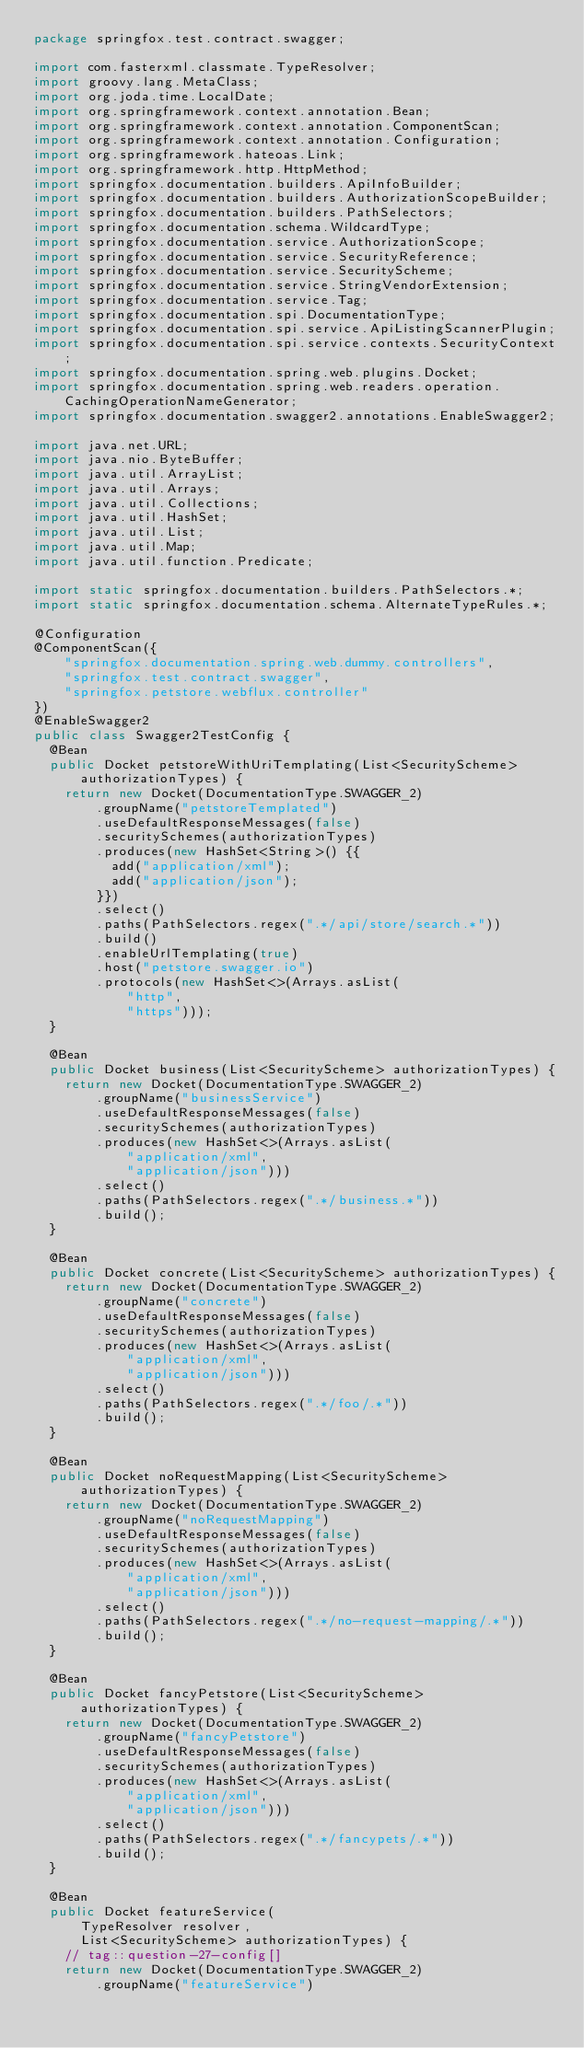<code> <loc_0><loc_0><loc_500><loc_500><_Java_>package springfox.test.contract.swagger;

import com.fasterxml.classmate.TypeResolver;
import groovy.lang.MetaClass;
import org.joda.time.LocalDate;
import org.springframework.context.annotation.Bean;
import org.springframework.context.annotation.ComponentScan;
import org.springframework.context.annotation.Configuration;
import org.springframework.hateoas.Link;
import org.springframework.http.HttpMethod;
import springfox.documentation.builders.ApiInfoBuilder;
import springfox.documentation.builders.AuthorizationScopeBuilder;
import springfox.documentation.builders.PathSelectors;
import springfox.documentation.schema.WildcardType;
import springfox.documentation.service.AuthorizationScope;
import springfox.documentation.service.SecurityReference;
import springfox.documentation.service.SecurityScheme;
import springfox.documentation.service.StringVendorExtension;
import springfox.documentation.service.Tag;
import springfox.documentation.spi.DocumentationType;
import springfox.documentation.spi.service.ApiListingScannerPlugin;
import springfox.documentation.spi.service.contexts.SecurityContext;
import springfox.documentation.spring.web.plugins.Docket;
import springfox.documentation.spring.web.readers.operation.CachingOperationNameGenerator;
import springfox.documentation.swagger2.annotations.EnableSwagger2;

import java.net.URL;
import java.nio.ByteBuffer;
import java.util.ArrayList;
import java.util.Arrays;
import java.util.Collections;
import java.util.HashSet;
import java.util.List;
import java.util.Map;
import java.util.function.Predicate;

import static springfox.documentation.builders.PathSelectors.*;
import static springfox.documentation.schema.AlternateTypeRules.*;

@Configuration
@ComponentScan({
    "springfox.documentation.spring.web.dummy.controllers",
    "springfox.test.contract.swagger",
    "springfox.petstore.webflux.controller"
})
@EnableSwagger2
public class Swagger2TestConfig {
  @Bean
  public Docket petstoreWithUriTemplating(List<SecurityScheme> authorizationTypes) {
    return new Docket(DocumentationType.SWAGGER_2)
        .groupName("petstoreTemplated")
        .useDefaultResponseMessages(false)
        .securitySchemes(authorizationTypes)
        .produces(new HashSet<String>() {{
          add("application/xml");
          add("application/json");
        }})
        .select()
        .paths(PathSelectors.regex(".*/api/store/search.*"))
        .build()
        .enableUrlTemplating(true)
        .host("petstore.swagger.io")
        .protocols(new HashSet<>(Arrays.asList(
            "http",
            "https")));
  }

  @Bean
  public Docket business(List<SecurityScheme> authorizationTypes) {
    return new Docket(DocumentationType.SWAGGER_2)
        .groupName("businessService")
        .useDefaultResponseMessages(false)
        .securitySchemes(authorizationTypes)
        .produces(new HashSet<>(Arrays.asList(
            "application/xml",
            "application/json")))
        .select()
        .paths(PathSelectors.regex(".*/business.*"))
        .build();
  }

  @Bean
  public Docket concrete(List<SecurityScheme> authorizationTypes) {
    return new Docket(DocumentationType.SWAGGER_2)
        .groupName("concrete")
        .useDefaultResponseMessages(false)
        .securitySchemes(authorizationTypes)
        .produces(new HashSet<>(Arrays.asList(
            "application/xml",
            "application/json")))
        .select()
        .paths(PathSelectors.regex(".*/foo/.*"))
        .build();
  }

  @Bean
  public Docket noRequestMapping(List<SecurityScheme> authorizationTypes) {
    return new Docket(DocumentationType.SWAGGER_2)
        .groupName("noRequestMapping")
        .useDefaultResponseMessages(false)
        .securitySchemes(authorizationTypes)
        .produces(new HashSet<>(Arrays.asList(
            "application/xml",
            "application/json")))
        .select()
        .paths(PathSelectors.regex(".*/no-request-mapping/.*"))
        .build();
  }

  @Bean
  public Docket fancyPetstore(List<SecurityScheme> authorizationTypes) {
    return new Docket(DocumentationType.SWAGGER_2)
        .groupName("fancyPetstore")
        .useDefaultResponseMessages(false)
        .securitySchemes(authorizationTypes)
        .produces(new HashSet<>(Arrays.asList(
            "application/xml",
            "application/json")))
        .select()
        .paths(PathSelectors.regex(".*/fancypets/.*"))
        .build();
  }

  @Bean
  public Docket featureService(
      TypeResolver resolver,
      List<SecurityScheme> authorizationTypes) {
    // tag::question-27-config[]
    return new Docket(DocumentationType.SWAGGER_2)
        .groupName("featureService")</code> 